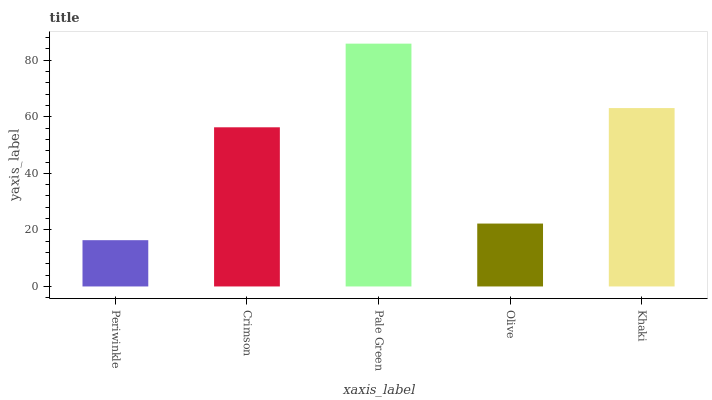Is Periwinkle the minimum?
Answer yes or no. Yes. Is Pale Green the maximum?
Answer yes or no. Yes. Is Crimson the minimum?
Answer yes or no. No. Is Crimson the maximum?
Answer yes or no. No. Is Crimson greater than Periwinkle?
Answer yes or no. Yes. Is Periwinkle less than Crimson?
Answer yes or no. Yes. Is Periwinkle greater than Crimson?
Answer yes or no. No. Is Crimson less than Periwinkle?
Answer yes or no. No. Is Crimson the high median?
Answer yes or no. Yes. Is Crimson the low median?
Answer yes or no. Yes. Is Pale Green the high median?
Answer yes or no. No. Is Pale Green the low median?
Answer yes or no. No. 